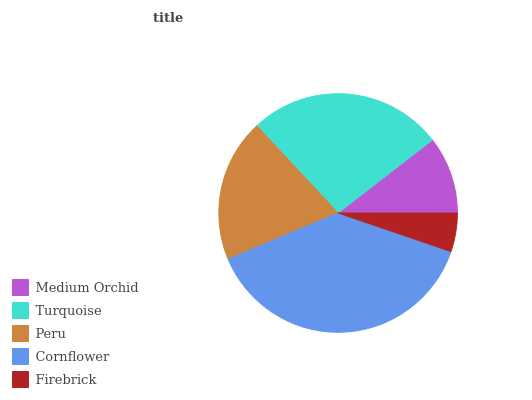Is Firebrick the minimum?
Answer yes or no. Yes. Is Cornflower the maximum?
Answer yes or no. Yes. Is Turquoise the minimum?
Answer yes or no. No. Is Turquoise the maximum?
Answer yes or no. No. Is Turquoise greater than Medium Orchid?
Answer yes or no. Yes. Is Medium Orchid less than Turquoise?
Answer yes or no. Yes. Is Medium Orchid greater than Turquoise?
Answer yes or no. No. Is Turquoise less than Medium Orchid?
Answer yes or no. No. Is Peru the high median?
Answer yes or no. Yes. Is Peru the low median?
Answer yes or no. Yes. Is Turquoise the high median?
Answer yes or no. No. Is Cornflower the low median?
Answer yes or no. No. 